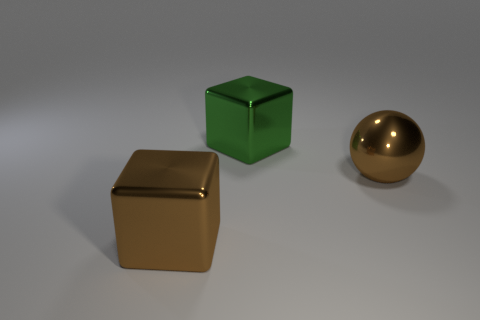Are there fewer brown metallic objects on the right side of the large metal sphere than big brown cubes that are in front of the brown metallic block?
Your answer should be very brief. No. Do the big brown cube and the big brown thing that is right of the green shiny block have the same material?
Give a very brief answer. Yes. Are there any other things that are made of the same material as the big ball?
Ensure brevity in your answer.  Yes. Is the number of balls greater than the number of brown cylinders?
Ensure brevity in your answer.  Yes. There is a brown thing to the left of the big metal block that is behind the shiny block in front of the large green block; what shape is it?
Make the answer very short. Cube. Is the brown thing left of the metallic sphere made of the same material as the brown thing that is on the right side of the large green thing?
Make the answer very short. Yes. What shape is the big green object that is made of the same material as the brown ball?
Offer a very short reply. Cube. Is there any other thing that has the same color as the ball?
Your answer should be compact. Yes. How many big objects are there?
Offer a very short reply. 3. There is a big brown object to the left of the object that is to the right of the big green block; what is its material?
Give a very brief answer. Metal. 